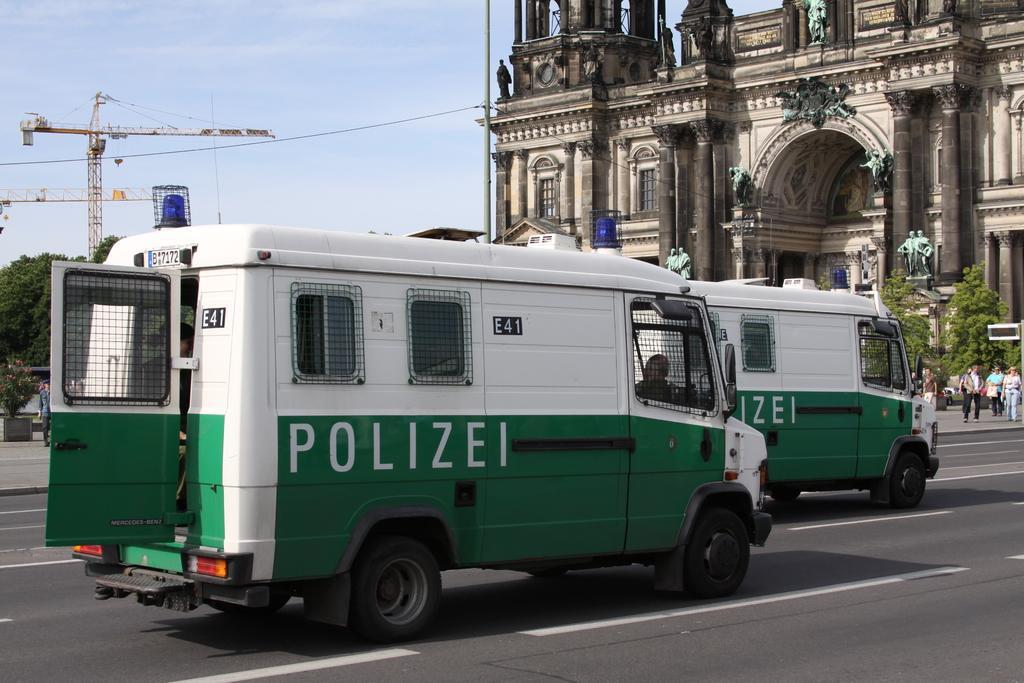In one or two sentences, can you explain what this image depicts? In the picture we can see a historical building with stone pillars and sculptures to it and near to it, we can see a tree and some people walking on the path and near the path we can see a road on it, we can see two police vans and in the background we can see some trees and behind it we can see a tower with a crane and behind it we can see a sky. 